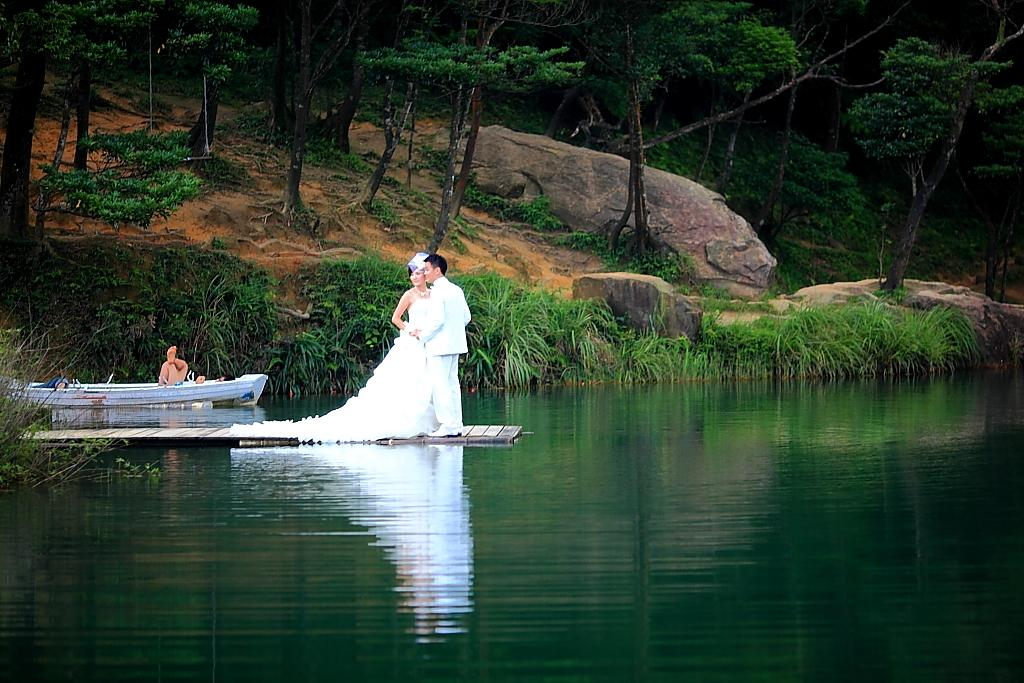Who can be seen in the image? There is a couple in the image. What are they standing on? The couple is standing on a wooden path. What type of vegetation is present in the image? There are plants, grass, and trees in the image. What body of water is visible in the image? There is a lake visible in the image. What type of dress is the committee wearing while playing the guitar in the image? There is no committee, dress, or guitar present in the image. 